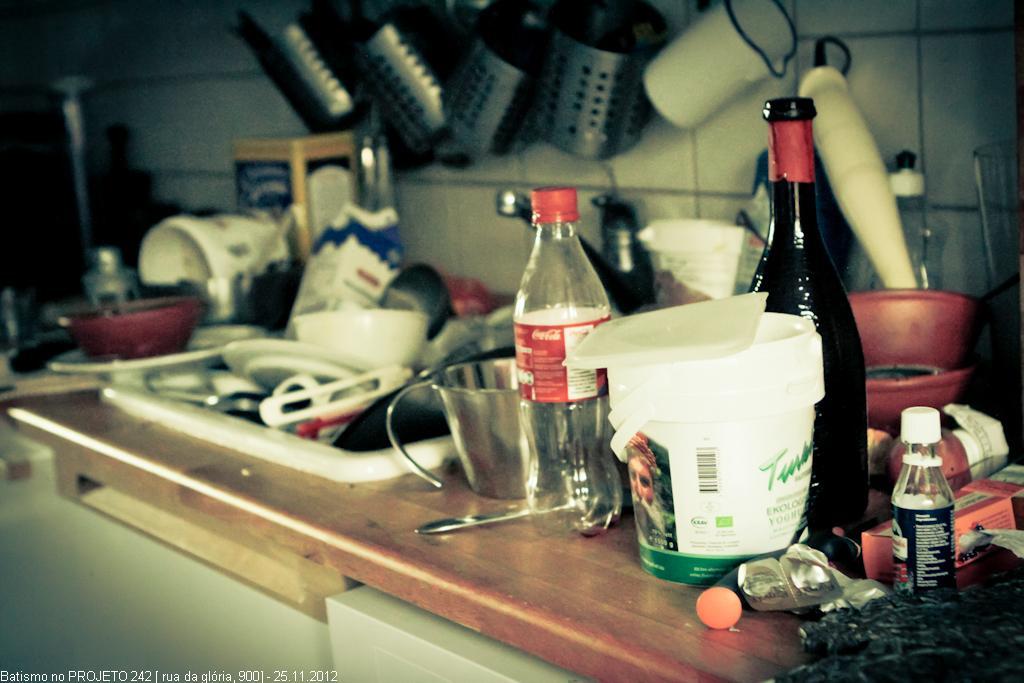In one or two sentences, can you explain what this image depicts? In this image I can see there are few bottles, utensils and other objects on the table. 